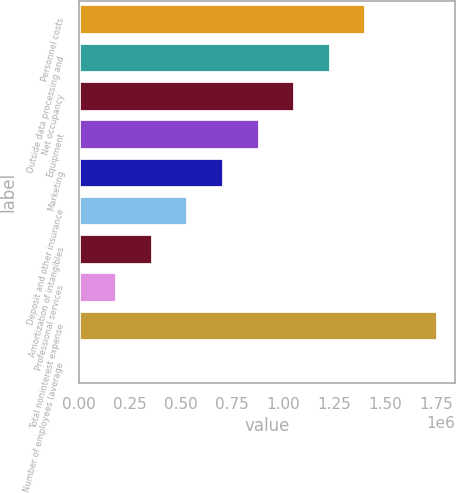Convert chart. <chart><loc_0><loc_0><loc_500><loc_500><bar_chart><fcel>Personnel costs<fcel>Outside data processing and<fcel>Net occupancy<fcel>Equipment<fcel>Marketing<fcel>Deposit and other insurance<fcel>Amortization of intangibles<fcel>Professional services<fcel>Total noninterest expense<fcel>Number of employees (average<nl><fcel>1.4088e+06<fcel>1.23419e+06<fcel>1.05959e+06<fcel>884984<fcel>710380<fcel>535776<fcel>361172<fcel>186568<fcel>1.758e+06<fcel>11964<nl></chart> 